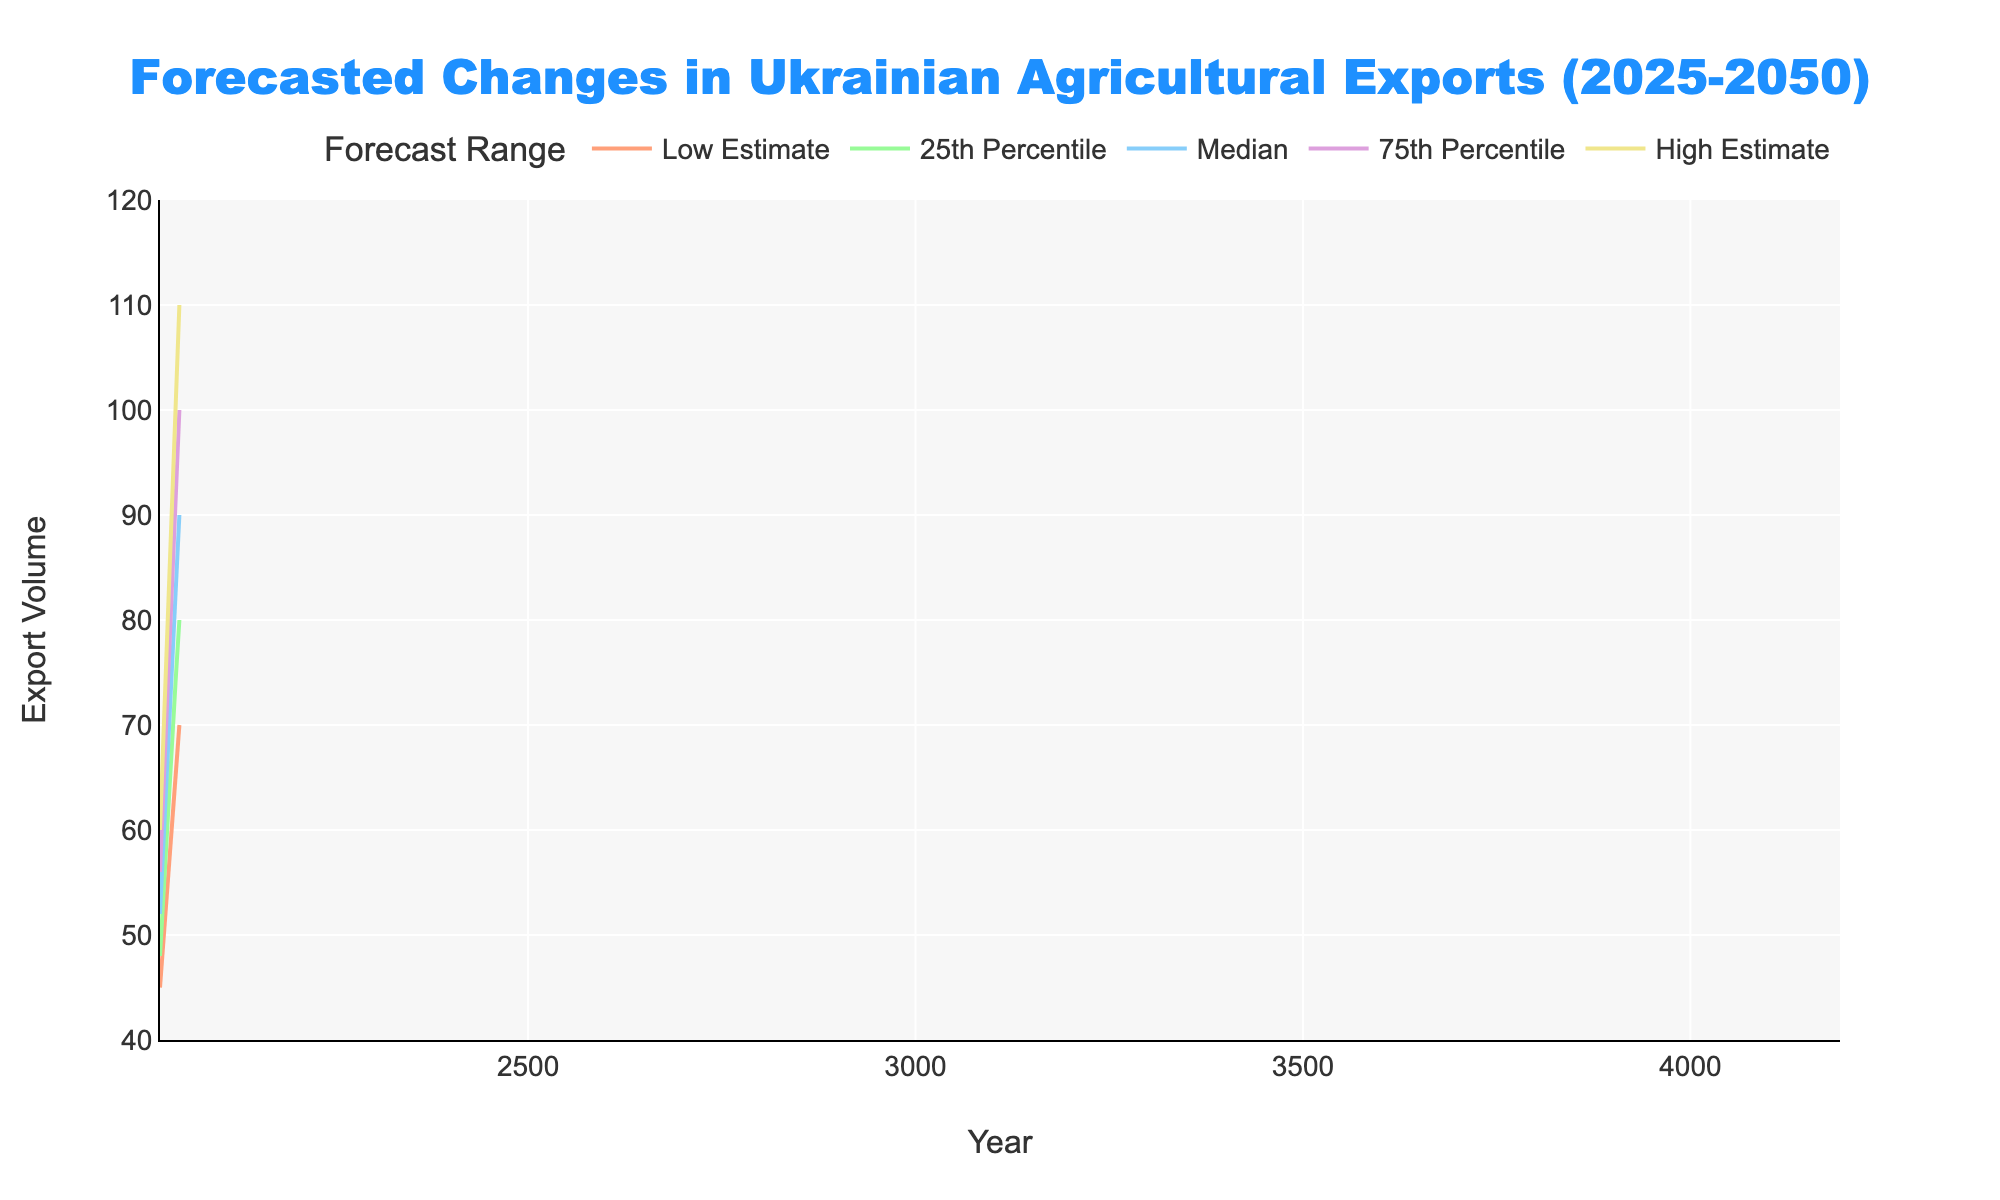What's the title of the figure? The title is displayed at the top center of the figure in a larger font.
Answer: "Forecasted Changes in Ukrainian Agricultural Exports (2025-2050)" How many forecast ranges are displayed in the figure? The legend at the top right of the figure shows five different forecast ranges. These are "Low Estimate," "25th Percentile," "Median," "75th Percentile," and "High Estimate."
Answer: 5 What is the median forecast value for the year 2040? Look at the year 2040 along the x-axis and find the corresponding median value from the y-axis.
Answer: 75 What is the difference between the high estimate and low estimate in 2050? Find the values for the high estimate and low estimate at the year 2050 on the y-axis and subtract the low estimate from the high estimate.
Answer: 40 In which year is the median forecast value highest? Compare the median forecast values across all years from 2025 to 2050, looking for the highest value.
Answer: 2050 How does the 75th percentile estimate change from 2025 to 2050? Observe the 75th percentile line from the year 2025 to 2050 and note the difference.
Answer: It increases from 56 to 100 By how much does the low estimate increase between 2025 and 2030? Subtract the low estimate value in 2025 from the low estimate value in 2030.
Answer: 5 Which year has the smallest range between the high estimate and low estimate? For each year, subtract the low estimate from the high estimate and identify the smallest difference.
Answer: 2025 What is the forecasted export volume range in 2045? Look at the high estimate and low estimate values for the year 2045 to get the range.
Answer: 65 to 98 